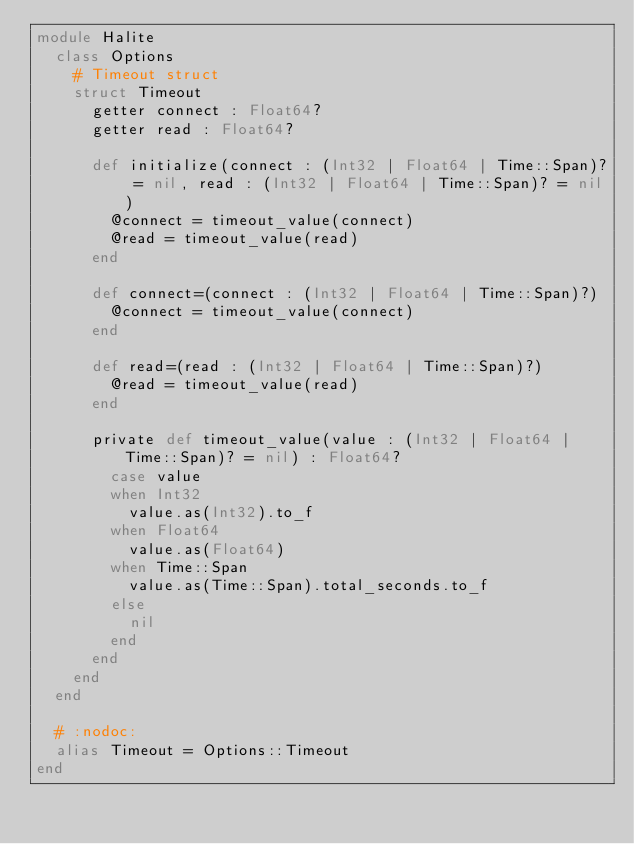Convert code to text. <code><loc_0><loc_0><loc_500><loc_500><_Crystal_>module Halite
  class Options
    # Timeout struct
    struct Timeout
      getter connect : Float64?
      getter read : Float64?

      def initialize(connect : (Int32 | Float64 | Time::Span)? = nil, read : (Int32 | Float64 | Time::Span)? = nil)
        @connect = timeout_value(connect)
        @read = timeout_value(read)
      end

      def connect=(connect : (Int32 | Float64 | Time::Span)?)
        @connect = timeout_value(connect)
      end

      def read=(read : (Int32 | Float64 | Time::Span)?)
        @read = timeout_value(read)
      end

      private def timeout_value(value : (Int32 | Float64 | Time::Span)? = nil) : Float64?
        case value
        when Int32
          value.as(Int32).to_f
        when Float64
          value.as(Float64)
        when Time::Span
          value.as(Time::Span).total_seconds.to_f
        else
          nil
        end
      end
    end
  end

  # :nodoc:
  alias Timeout = Options::Timeout
end
</code> 